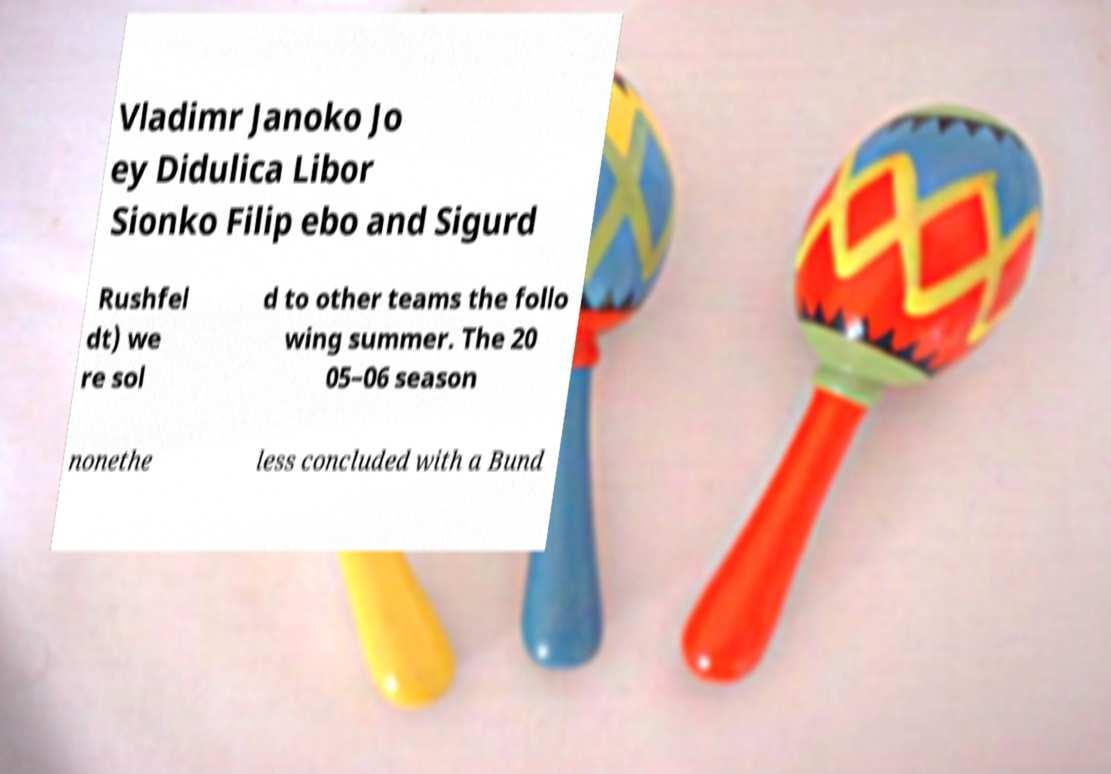Can you read and provide the text displayed in the image?This photo seems to have some interesting text. Can you extract and type it out for me? Vladimr Janoko Jo ey Didulica Libor Sionko Filip ebo and Sigurd Rushfel dt) we re sol d to other teams the follo wing summer. The 20 05–06 season nonethe less concluded with a Bund 